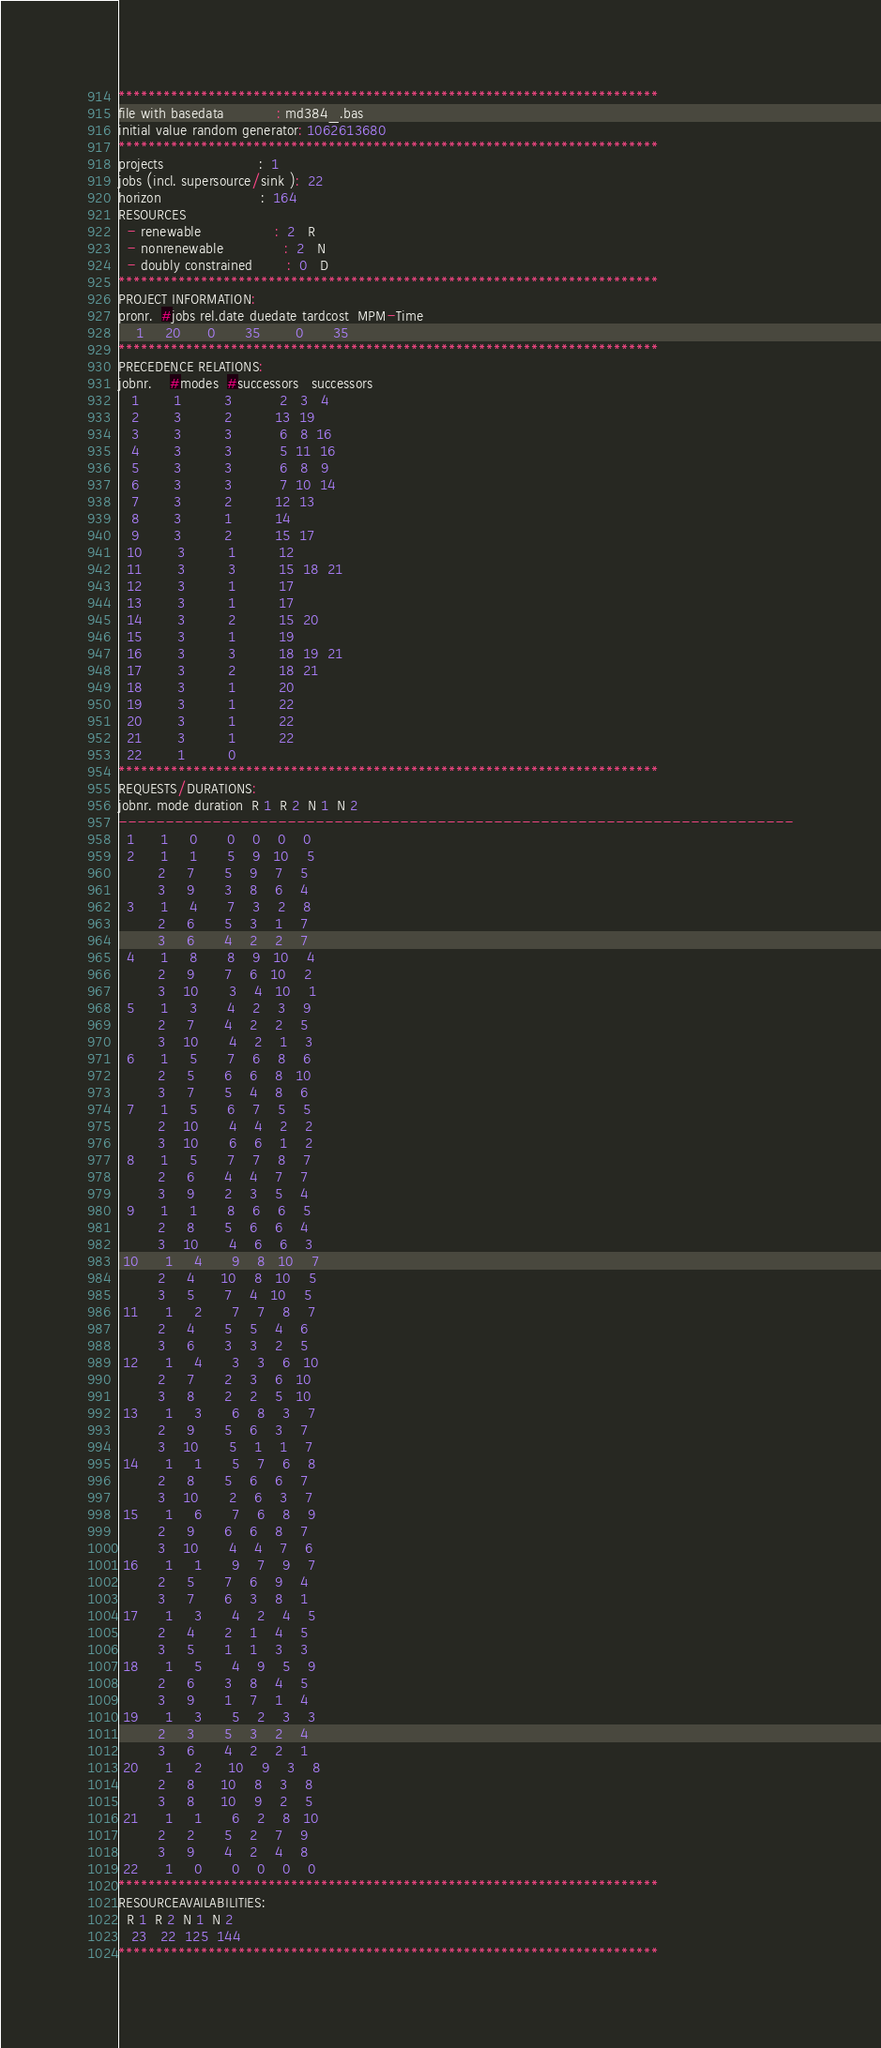Convert code to text. <code><loc_0><loc_0><loc_500><loc_500><_ObjectiveC_>************************************************************************
file with basedata            : md384_.bas
initial value random generator: 1062613680
************************************************************************
projects                      :  1
jobs (incl. supersource/sink ):  22
horizon                       :  164
RESOURCES
  - renewable                 :  2   R
  - nonrenewable              :  2   N
  - doubly constrained        :  0   D
************************************************************************
PROJECT INFORMATION:
pronr.  #jobs rel.date duedate tardcost  MPM-Time
    1     20      0       35        0       35
************************************************************************
PRECEDENCE RELATIONS:
jobnr.    #modes  #successors   successors
   1        1          3           2   3   4
   2        3          2          13  19
   3        3          3           6   8  16
   4        3          3           5  11  16
   5        3          3           6   8   9
   6        3          3           7  10  14
   7        3          2          12  13
   8        3          1          14
   9        3          2          15  17
  10        3          1          12
  11        3          3          15  18  21
  12        3          1          17
  13        3          1          17
  14        3          2          15  20
  15        3          1          19
  16        3          3          18  19  21
  17        3          2          18  21
  18        3          1          20
  19        3          1          22
  20        3          1          22
  21        3          1          22
  22        1          0        
************************************************************************
REQUESTS/DURATIONS:
jobnr. mode duration  R 1  R 2  N 1  N 2
------------------------------------------------------------------------
  1      1     0       0    0    0    0
  2      1     1       5    9   10    5
         2     7       5    9    7    5
         3     9       3    8    6    4
  3      1     4       7    3    2    8
         2     6       5    3    1    7
         3     6       4    2    2    7
  4      1     8       8    9   10    4
         2     9       7    6   10    2
         3    10       3    4   10    1
  5      1     3       4    2    3    9
         2     7       4    2    2    5
         3    10       4    2    1    3
  6      1     5       7    6    8    6
         2     5       6    6    8   10
         3     7       5    4    8    6
  7      1     5       6    7    5    5
         2    10       4    4    2    2
         3    10       6    6    1    2
  8      1     5       7    7    8    7
         2     6       4    4    7    7
         3     9       2    3    5    4
  9      1     1       8    6    6    5
         2     8       5    6    6    4
         3    10       4    6    6    3
 10      1     4       9    8   10    7
         2     4      10    8   10    5
         3     5       7    4   10    5
 11      1     2       7    7    8    7
         2     4       5    5    4    6
         3     6       3    3    2    5
 12      1     4       3    3    6   10
         2     7       2    3    6   10
         3     8       2    2    5   10
 13      1     3       6    8    3    7
         2     9       5    6    3    7
         3    10       5    1    1    7
 14      1     1       5    7    6    8
         2     8       5    6    6    7
         3    10       2    6    3    7
 15      1     6       7    6    8    9
         2     9       6    6    8    7
         3    10       4    4    7    6
 16      1     1       9    7    9    7
         2     5       7    6    9    4
         3     7       6    3    8    1
 17      1     3       4    2    4    5
         2     4       2    1    4    5
         3     5       1    1    3    3
 18      1     5       4    9    5    9
         2     6       3    8    4    5
         3     9       1    7    1    4
 19      1     3       5    2    3    3
         2     3       5    3    2    4
         3     6       4    2    2    1
 20      1     2      10    9    3    8
         2     8      10    8    3    8
         3     8      10    9    2    5
 21      1     1       6    2    8   10
         2     2       5    2    7    9
         3     9       4    2    4    8
 22      1     0       0    0    0    0
************************************************************************
RESOURCEAVAILABILITIES:
  R 1  R 2  N 1  N 2
   23   22  125  144
************************************************************************
</code> 